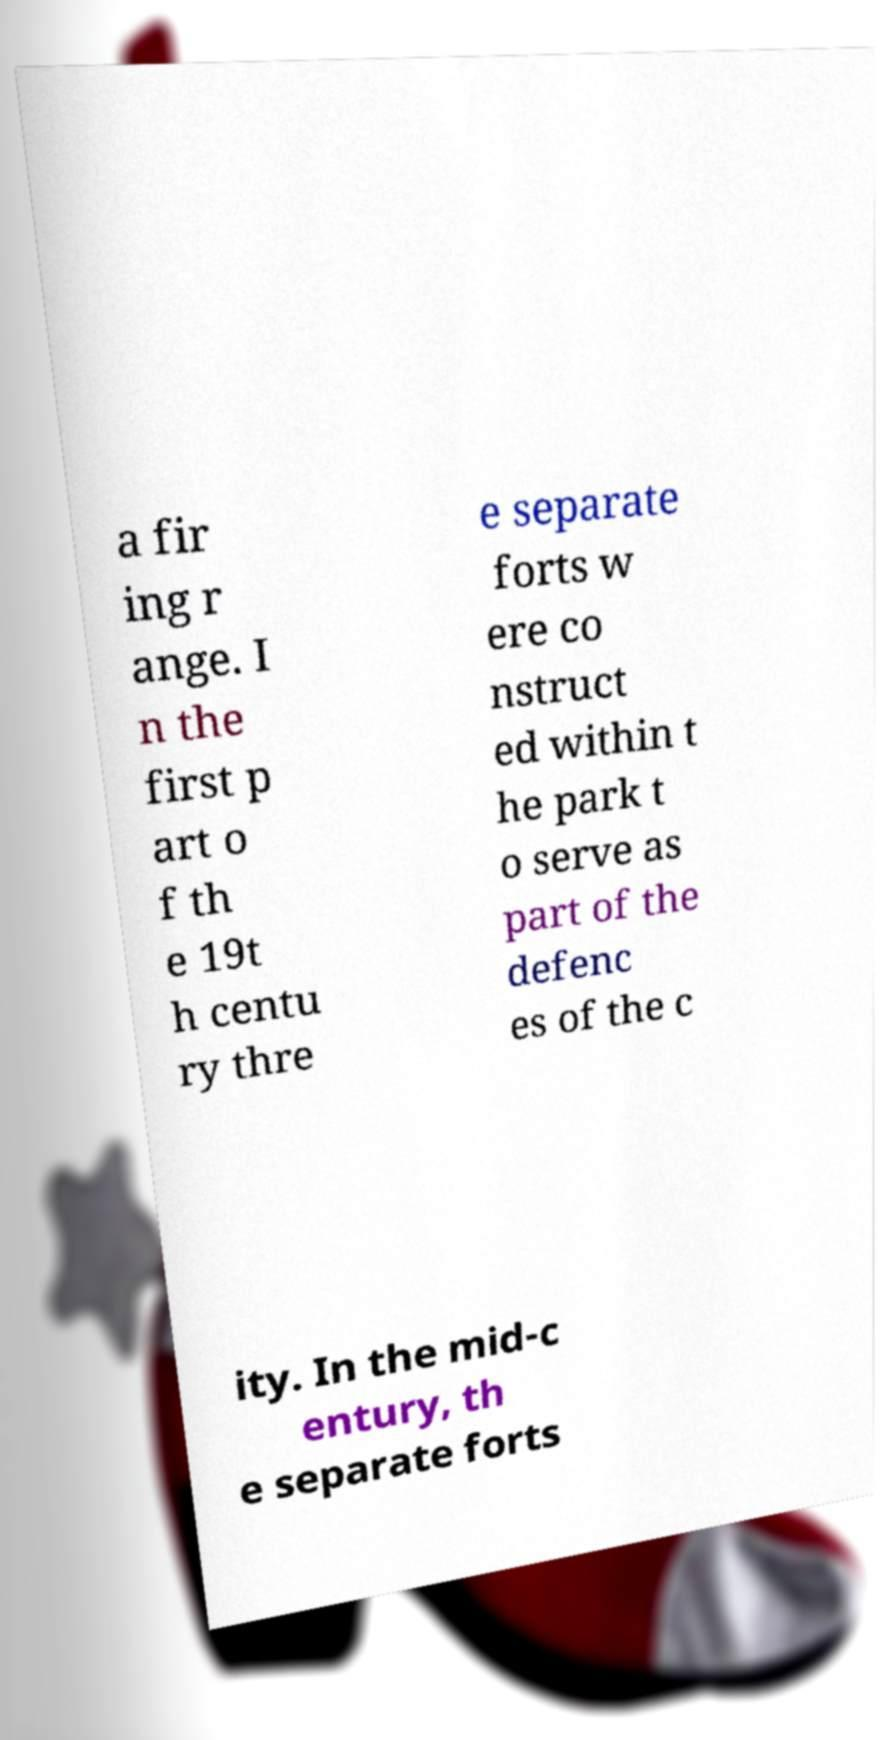Can you read and provide the text displayed in the image?This photo seems to have some interesting text. Can you extract and type it out for me? a fir ing r ange. I n the first p art o f th e 19t h centu ry thre e separate forts w ere co nstruct ed within t he park t o serve as part of the defenc es of the c ity. In the mid-c entury, th e separate forts 